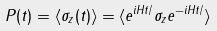<formula> <loc_0><loc_0><loc_500><loc_500>P ( t ) = \langle \sigma _ { z } ( t ) \rangle = \langle e ^ { i H t / } \sigma _ { z } e ^ { - i H t / } \rangle</formula> 